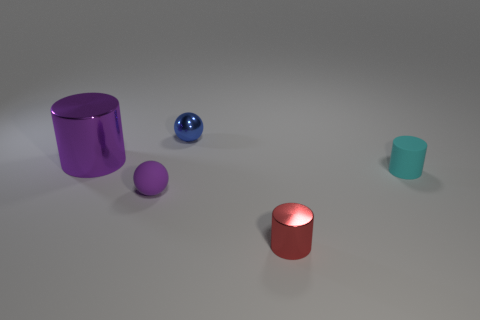Add 1 small brown shiny objects. How many objects exist? 6 Subtract all cylinders. How many objects are left? 2 Add 2 small blue spheres. How many small blue spheres exist? 3 Subtract 0 brown balls. How many objects are left? 5 Subtract all tiny cylinders. Subtract all big cyan cylinders. How many objects are left? 3 Add 1 purple cylinders. How many purple cylinders are left? 2 